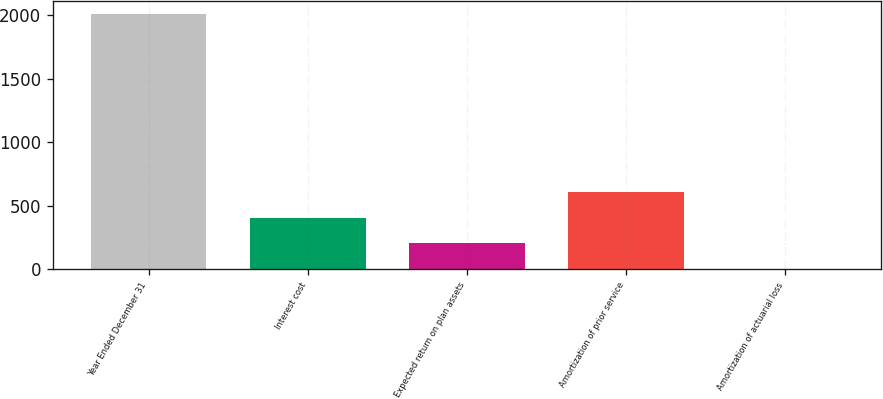Convert chart to OTSL. <chart><loc_0><loc_0><loc_500><loc_500><bar_chart><fcel>Year Ended December 31<fcel>Interest cost<fcel>Expected return on plan assets<fcel>Amortization of prior service<fcel>Amortization of actuarial loss<nl><fcel>2011<fcel>403.8<fcel>202.9<fcel>604.7<fcel>2<nl></chart> 